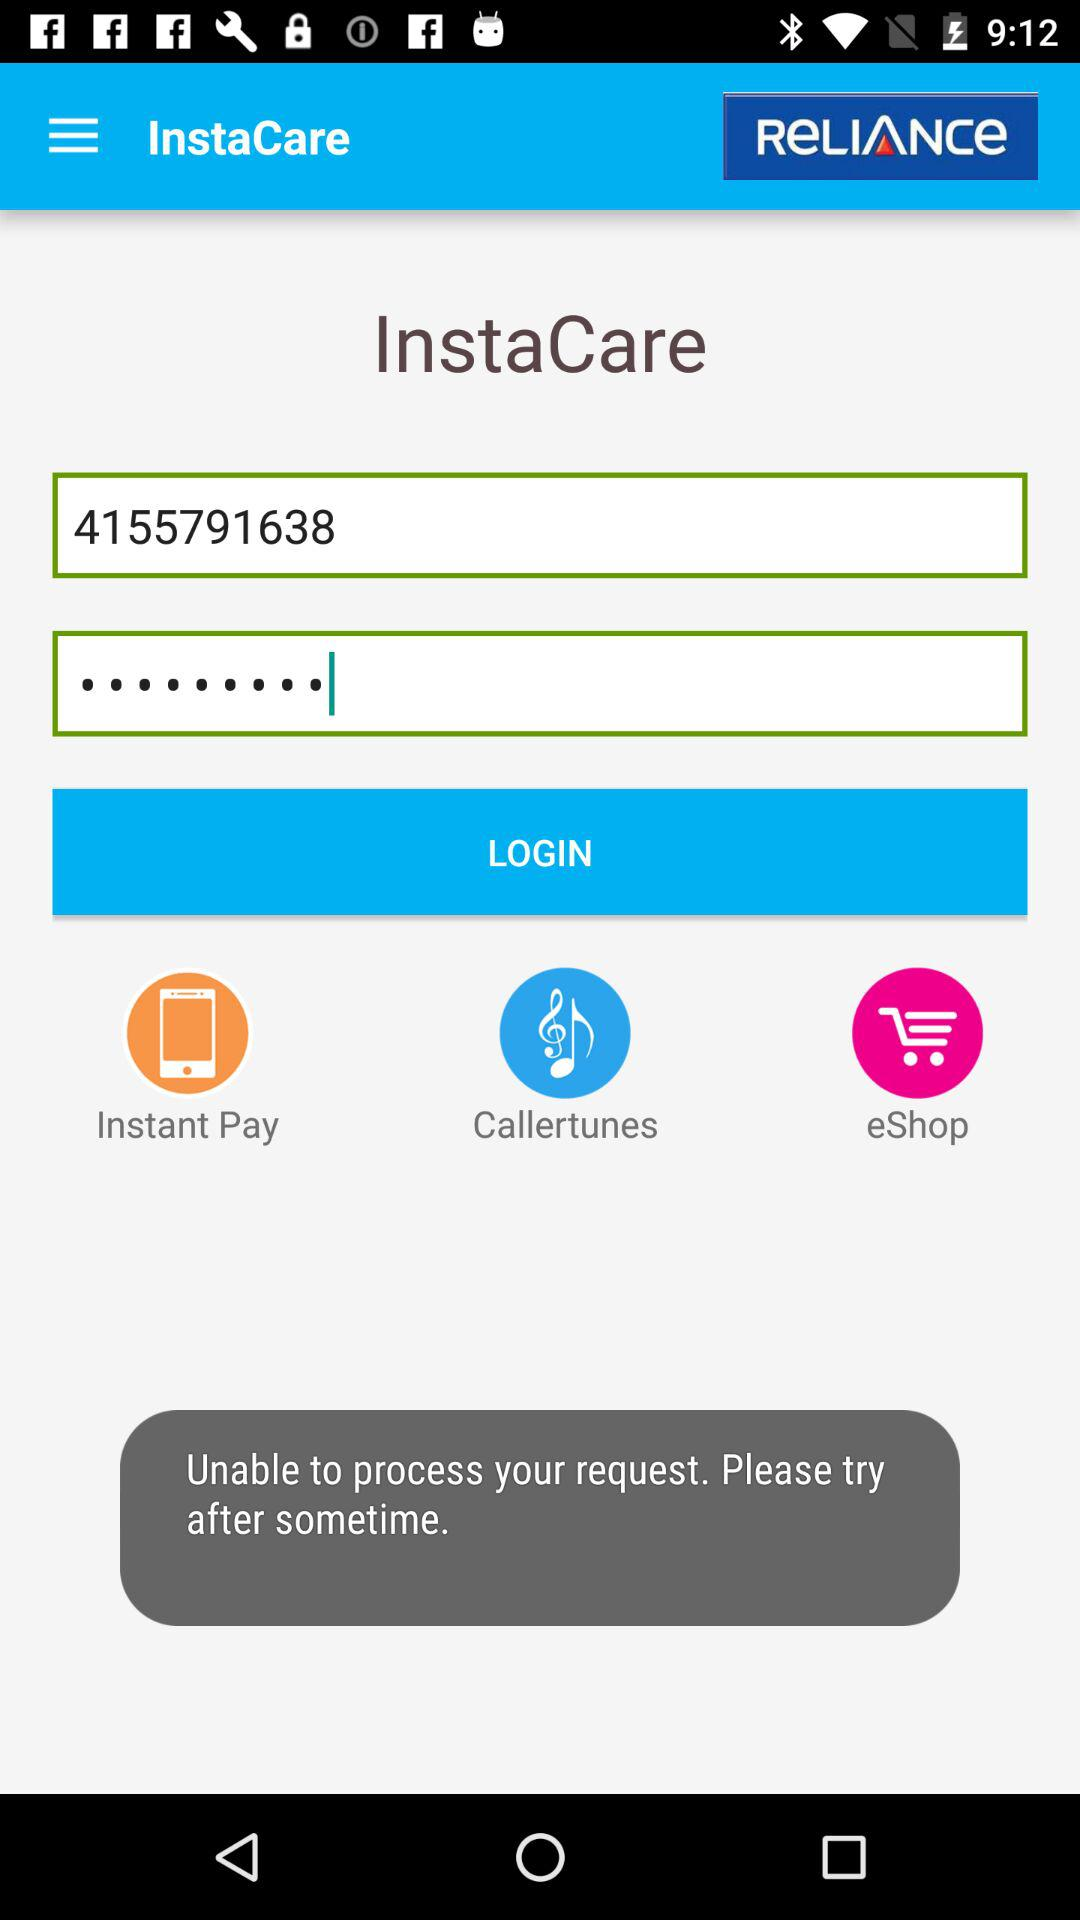What is the application name? The application name is "Reliance". 